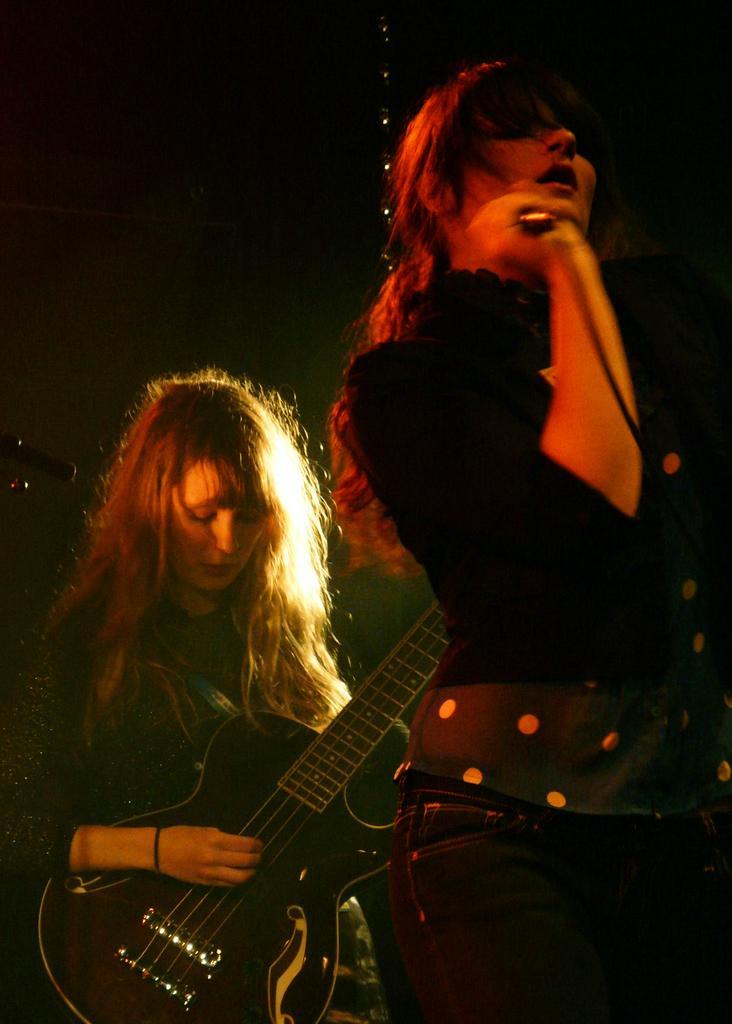Can you describe this image briefly? This picture shows a woman playing a guitar in her hands. In front of her there is another woman singing, holding a mic in her hands. 